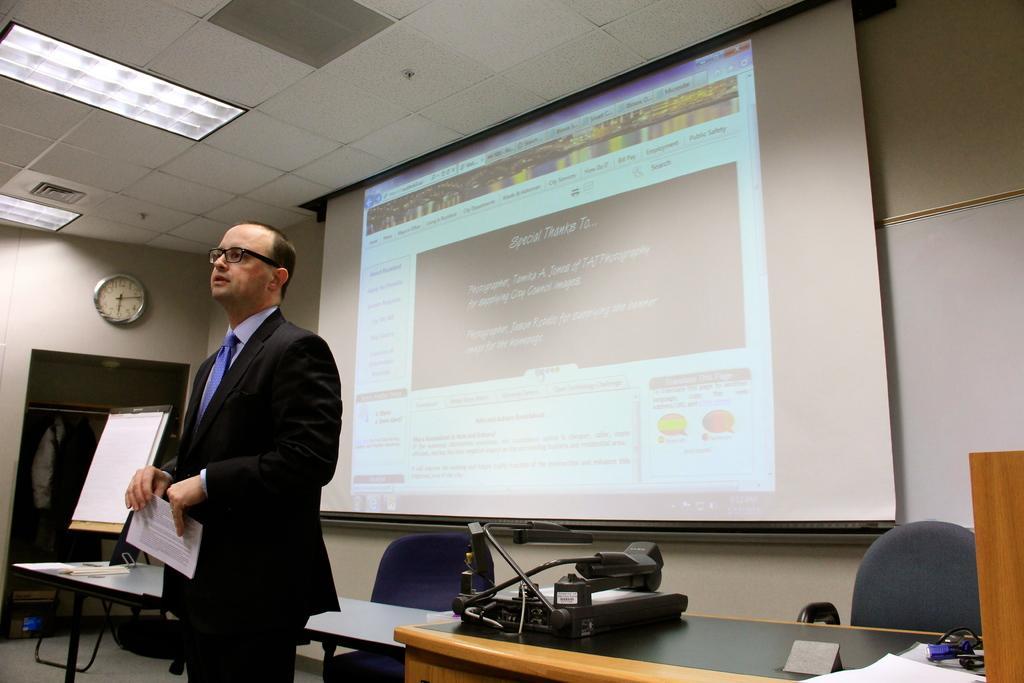How would you summarize this image in a sentence or two? This picture shows a man standing wearing a spectacles, holding a paper in his hand in front of a table. There is a chair and equipment on the table. In the background there is a projector display screen and a board. We can observe a wall clock, hanged to the wall. 